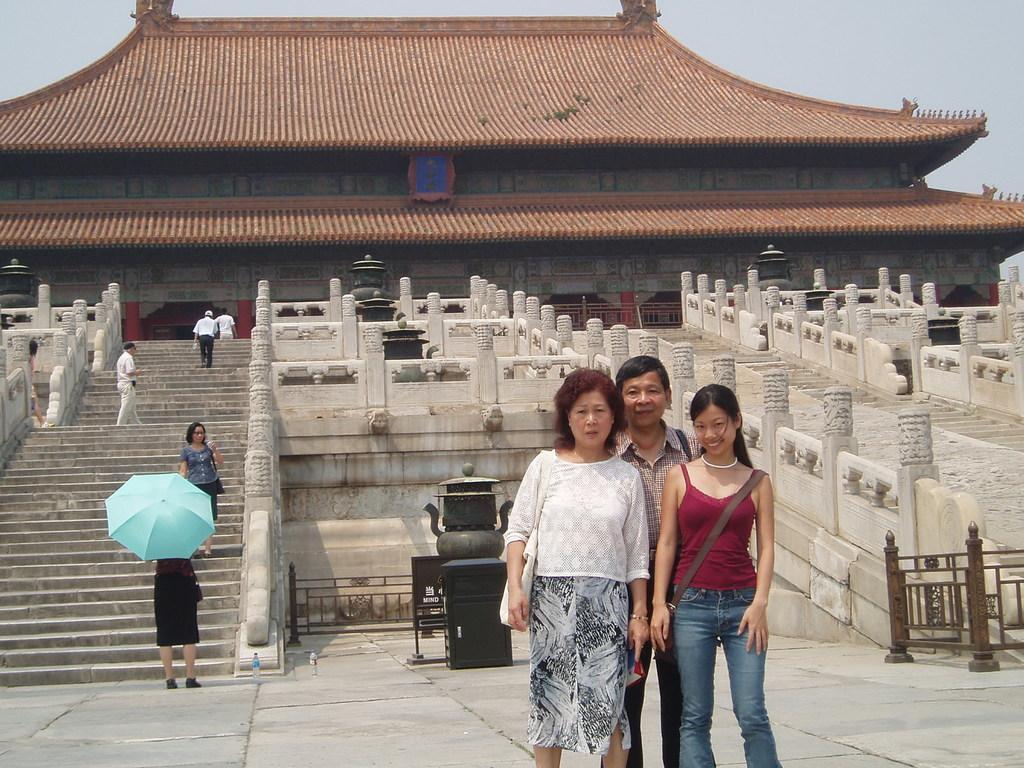Could you give a brief overview of what you see in this image? In the center of the image there are three people standing on the path. In the background we can see a monument and also stairs. Sky is also visible. 